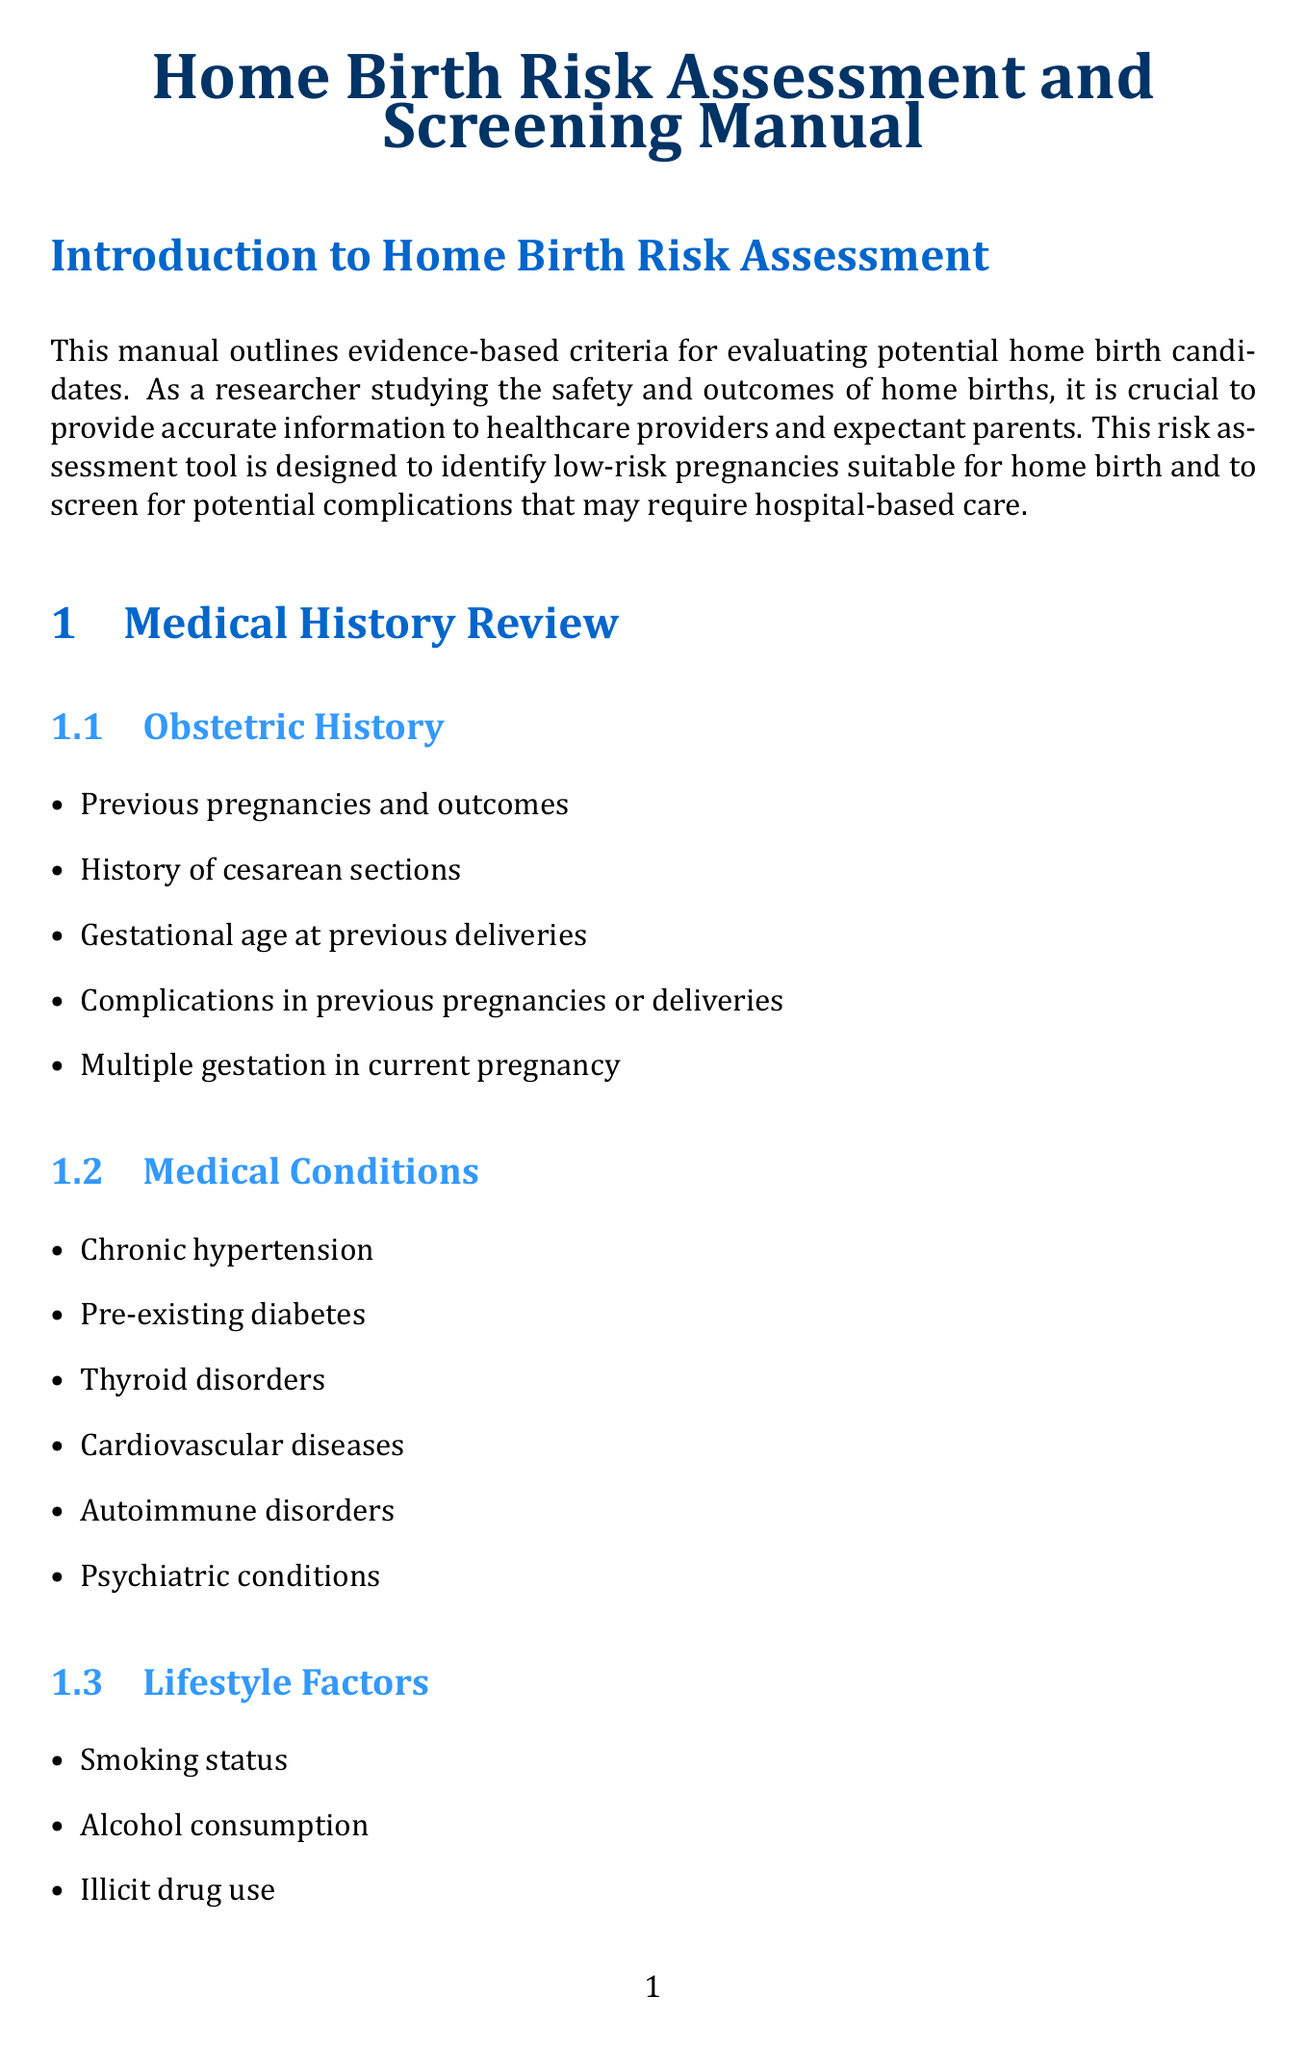What is the main purpose of the manual? The manual outlines evidence-based criteria for evaluating potential home birth candidates.
Answer: Evaluating potential home birth candidates What is one criterion under Medical Conditions? A criterion listed in the Medical Conditions section is chronic hypertension.
Answer: Chronic hypertension What is the age considered as advanced maternal age? Advanced maternal age is classified as being over 35 years old.
Answer: >35 years What risk level is suitable for home birth with minimal concerns? The risk level suitable for home birth with minimal concerns is Low Risk.
Answer: Low Risk How many laboratory tests are listed in the Laboratory Tests section? There are seven tests listed in the Laboratory Tests section.
Answer: Seven Which manual section includes emergency transfer protocols? The section that includes emergency transfer protocols is Informed Decision Making.
Answer: Informed Decision Making What should be evaluated during the General Health Assessment? Blood pressure measurement is one of the evaluations during the General Health Assessment.
Answer: Blood pressure measurement What is the recommended BMI range for Low Risk? The BMI range recommended for Low Risk is between 18.5 and 35.
Answer: 18.5 and 35 